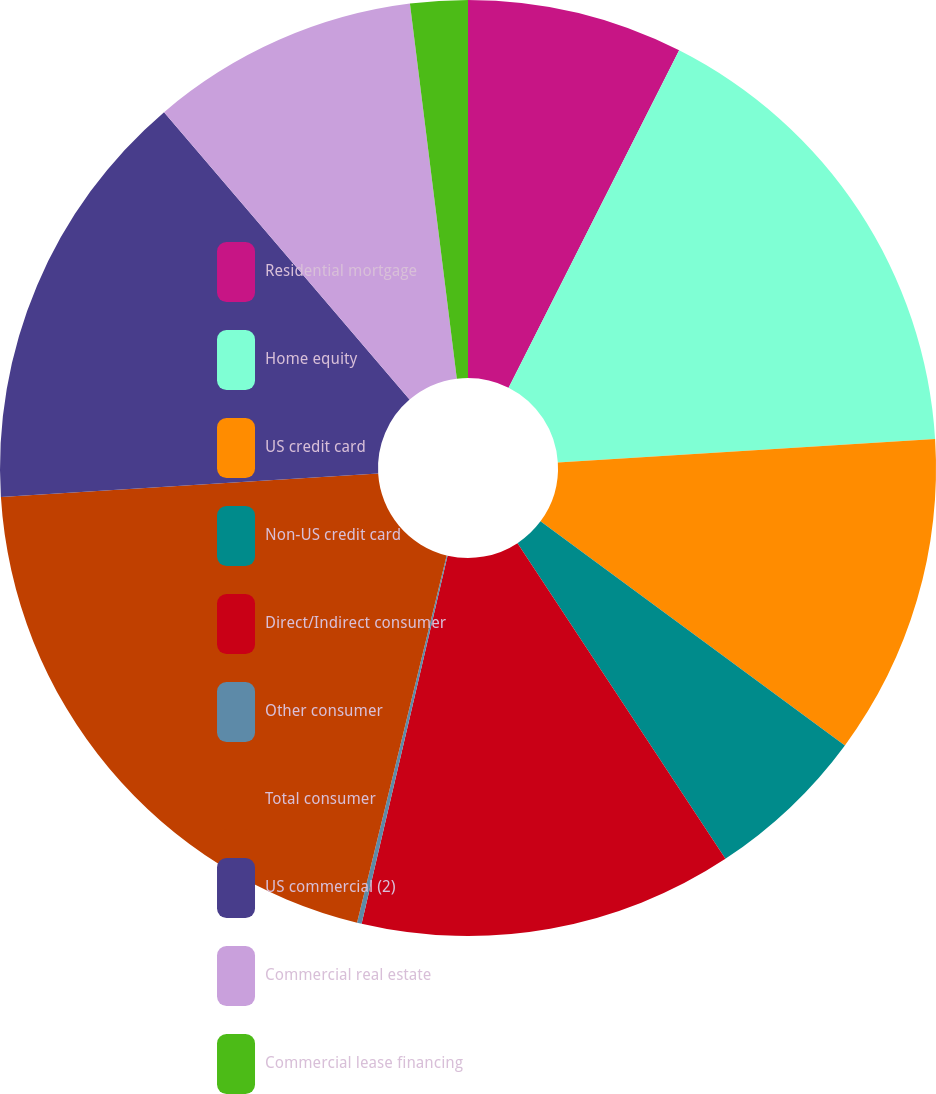Convert chart to OTSL. <chart><loc_0><loc_0><loc_500><loc_500><pie_chart><fcel>Residential mortgage<fcel>Home equity<fcel>US credit card<fcel>Non-US credit card<fcel>Direct/Indirect consumer<fcel>Other consumer<fcel>Total consumer<fcel>US commercial (2)<fcel>Commercial real estate<fcel>Commercial lease financing<nl><fcel>7.45%<fcel>16.56%<fcel>11.09%<fcel>5.63%<fcel>12.92%<fcel>0.16%<fcel>20.2%<fcel>14.74%<fcel>9.27%<fcel>1.98%<nl></chart> 